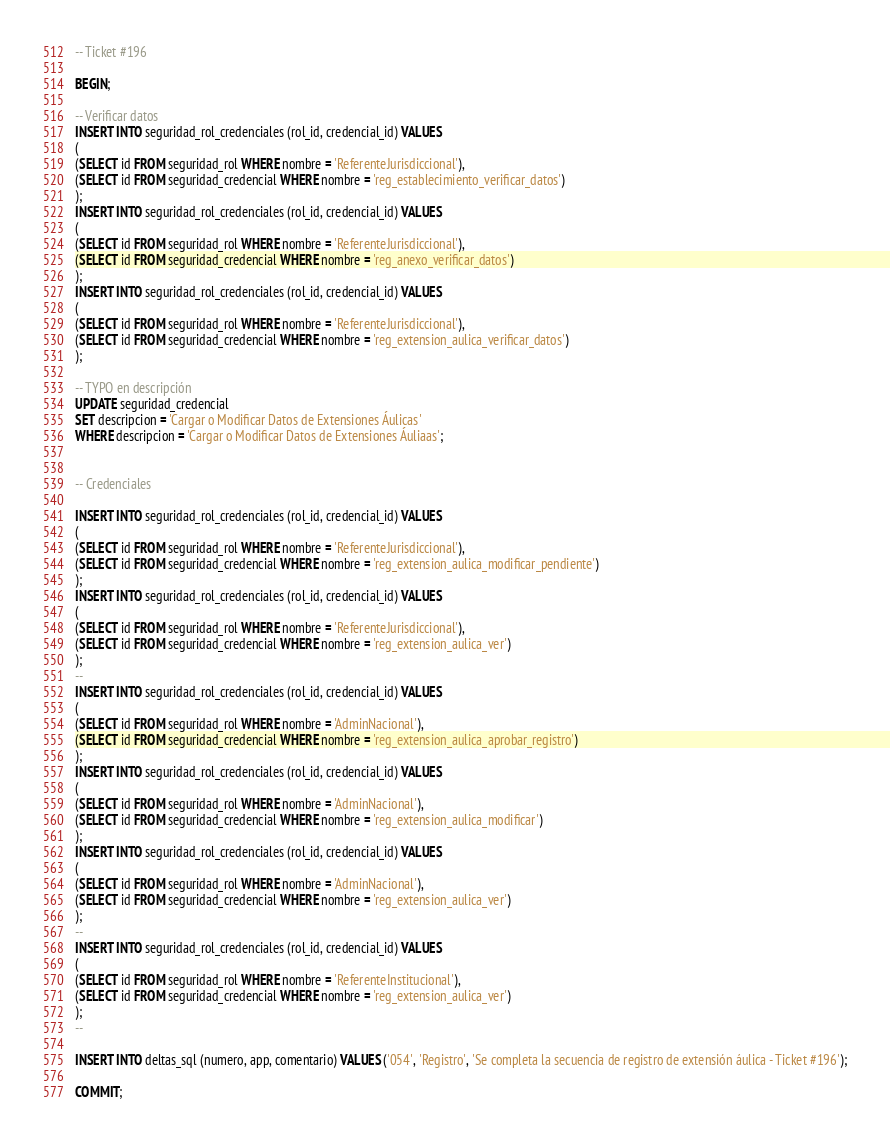<code> <loc_0><loc_0><loc_500><loc_500><_SQL_>-- Ticket #196

BEGIN;

-- Verificar datos
INSERT INTO seguridad_rol_credenciales (rol_id, credencial_id) VALUES
(
(SELECT id FROM seguridad_rol WHERE nombre = 'ReferenteJurisdiccional'), 
(SELECT id FROM seguridad_credencial WHERE nombre = 'reg_establecimiento_verificar_datos')
);
INSERT INTO seguridad_rol_credenciales (rol_id, credencial_id) VALUES
(
(SELECT id FROM seguridad_rol WHERE nombre = 'ReferenteJurisdiccional'), 
(SELECT id FROM seguridad_credencial WHERE nombre = 'reg_anexo_verificar_datos')
);
INSERT INTO seguridad_rol_credenciales (rol_id, credencial_id) VALUES
(
(SELECT id FROM seguridad_rol WHERE nombre = 'ReferenteJurisdiccional'), 
(SELECT id FROM seguridad_credencial WHERE nombre = 'reg_extension_aulica_verificar_datos')
);

-- TYPO en descripción
UPDATE seguridad_credencial
SET descripcion = 'Cargar o Modificar Datos de Extensiones Áulicas'
WHERE descripcion = 'Cargar o Modificar Datos de Extensiones Áuliaas';


-- Credenciales

INSERT INTO seguridad_rol_credenciales (rol_id, credencial_id) VALUES
(
(SELECT id FROM seguridad_rol WHERE nombre = 'ReferenteJurisdiccional'), 
(SELECT id FROM seguridad_credencial WHERE nombre = 'reg_extension_aulica_modificar_pendiente')
);
INSERT INTO seguridad_rol_credenciales (rol_id, credencial_id) VALUES
(
(SELECT id FROM seguridad_rol WHERE nombre = 'ReferenteJurisdiccional'), 
(SELECT id FROM seguridad_credencial WHERE nombre = 'reg_extension_aulica_ver')
);
--
INSERT INTO seguridad_rol_credenciales (rol_id, credencial_id) VALUES
(
(SELECT id FROM seguridad_rol WHERE nombre = 'AdminNacional'), 
(SELECT id FROM seguridad_credencial WHERE nombre = 'reg_extension_aulica_aprobar_registro')
);
INSERT INTO seguridad_rol_credenciales (rol_id, credencial_id) VALUES
(
(SELECT id FROM seguridad_rol WHERE nombre = 'AdminNacional'), 
(SELECT id FROM seguridad_credencial WHERE nombre = 'reg_extension_aulica_modificar')
);
INSERT INTO seguridad_rol_credenciales (rol_id, credencial_id) VALUES
(
(SELECT id FROM seguridad_rol WHERE nombre = 'AdminNacional'), 
(SELECT id FROM seguridad_credencial WHERE nombre = 'reg_extension_aulica_ver')
);
--
INSERT INTO seguridad_rol_credenciales (rol_id, credencial_id) VALUES
(
(SELECT id FROM seguridad_rol WHERE nombre = 'ReferenteInstitucional'), 
(SELECT id FROM seguridad_credencial WHERE nombre = 'reg_extension_aulica_ver')
);
--

INSERT INTO deltas_sql (numero, app, comentario) VALUES ('054', 'Registro', 'Se completa la secuencia de registro de extensión áulica - Ticket #196');

COMMIT;

</code> 